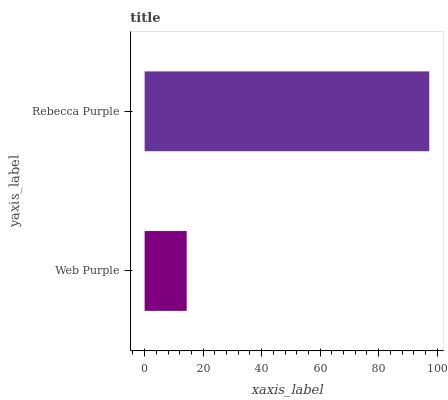Is Web Purple the minimum?
Answer yes or no. Yes. Is Rebecca Purple the maximum?
Answer yes or no. Yes. Is Rebecca Purple the minimum?
Answer yes or no. No. Is Rebecca Purple greater than Web Purple?
Answer yes or no. Yes. Is Web Purple less than Rebecca Purple?
Answer yes or no. Yes. Is Web Purple greater than Rebecca Purple?
Answer yes or no. No. Is Rebecca Purple less than Web Purple?
Answer yes or no. No. Is Rebecca Purple the high median?
Answer yes or no. Yes. Is Web Purple the low median?
Answer yes or no. Yes. Is Web Purple the high median?
Answer yes or no. No. Is Rebecca Purple the low median?
Answer yes or no. No. 